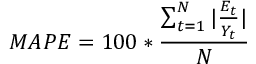<formula> <loc_0><loc_0><loc_500><loc_500>\ M A P E = 1 0 0 * { \frac { \sum _ { t = 1 } ^ { N } | { \frac { E _ { t } } { Y _ { t } } } | } { N } }</formula> 